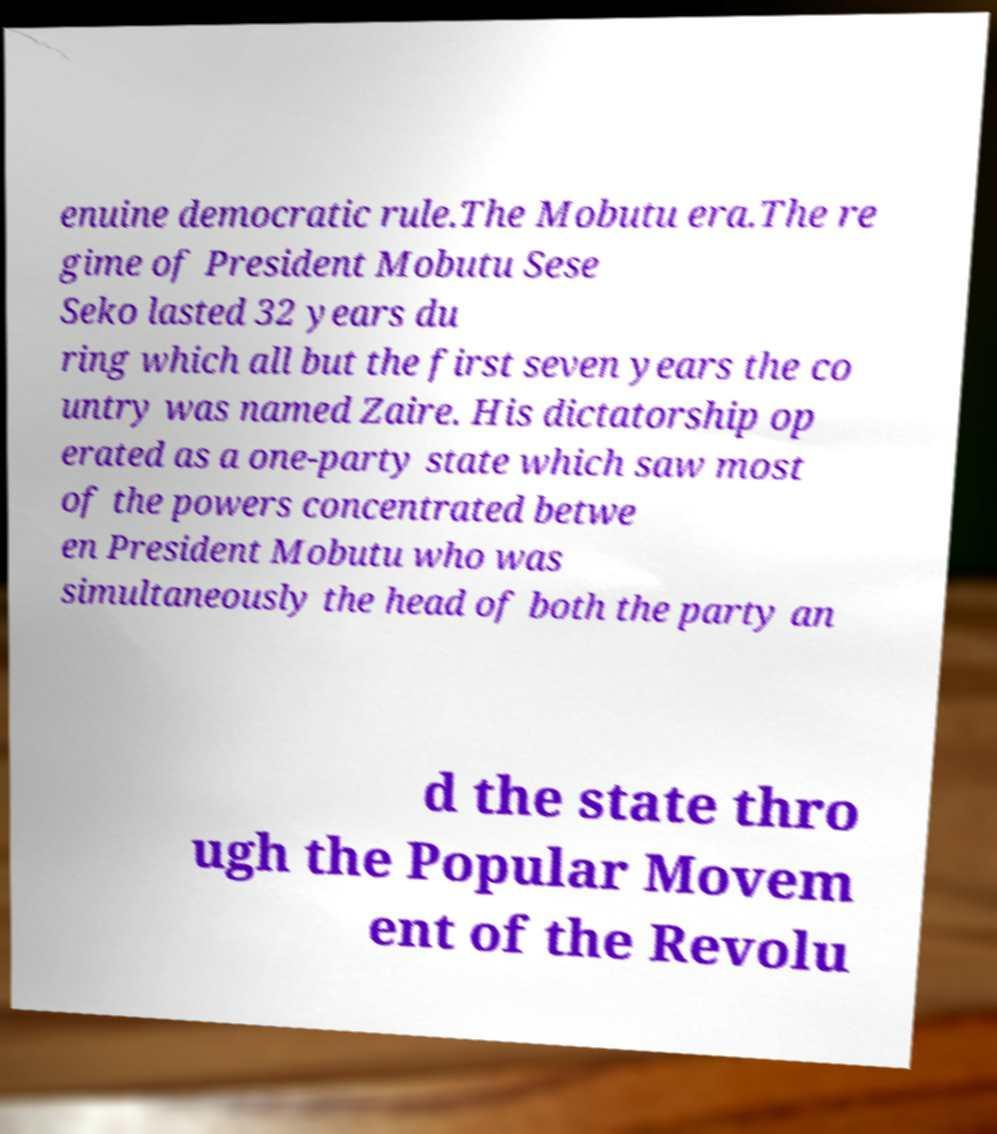Could you extract and type out the text from this image? enuine democratic rule.The Mobutu era.The re gime of President Mobutu Sese Seko lasted 32 years du ring which all but the first seven years the co untry was named Zaire. His dictatorship op erated as a one-party state which saw most of the powers concentrated betwe en President Mobutu who was simultaneously the head of both the party an d the state thro ugh the Popular Movem ent of the Revolu 